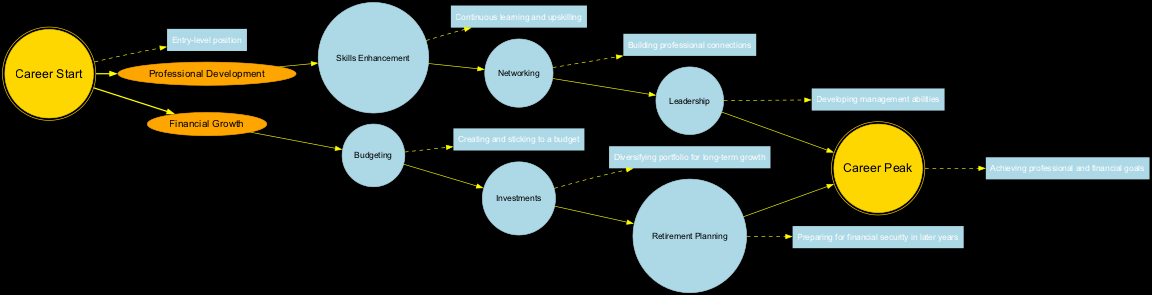What is the name of the center node in the diagram? The center node is labeled "Career Start", which represents the entry-level position in the career growth trajectory.
Answer: Career Start How many arms are present in the diagram? There are two arms in the diagram, representing "Professional Development" and "Financial Growth."
Answer: 2 What is the description of the outer ring node? The outer ring node is described as "Achieving professional and financial goals," indicating the peak of the career trajectory.
Answer: Achieving professional and financial goals Which node focuses on continuous learning and upskilling? The node that focuses on continuous learning and upskilling is "Skills Enhancement," found under the "Professional Development" arm.
Answer: Skills Enhancement What are the two main areas represented by the arms? The two main areas represented by the arms are "Professional Development" and "Financial Growth," which detail the paths toward career and financial advancement.
Answer: Professional Development and Financial Growth Which node is connected directly to the center node? The arms "Professional Development" and "Financial Growth" are each connected directly to the center node, showing the initial paths for career development.
Answer: Professional Development and Financial Growth What type of planning is discussed in the Financial Growth arm? The Financial Growth arm discusses "Retirement Planning," which emphasizes preparing for financial security in later years.
Answer: Retirement Planning Name one of the focuses of the Leadership node. The Leadership node focuses on developing management abilities to enhance professional progression and influence.
Answer: Developing management abilities How does the "Networking" node relate to career advancement? The "Networking" node relates to career advancement by emphasizing the importance of building professional connections that can lead to new opportunities and collaborations.
Answer: Building professional connections 